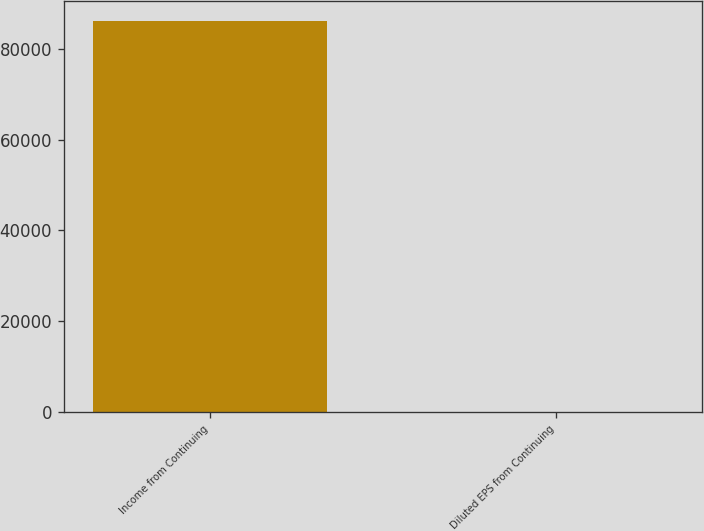<chart> <loc_0><loc_0><loc_500><loc_500><bar_chart><fcel>Income from Continuing<fcel>Diluted EPS from Continuing<nl><fcel>86091.9<fcel>2.79<nl></chart> 